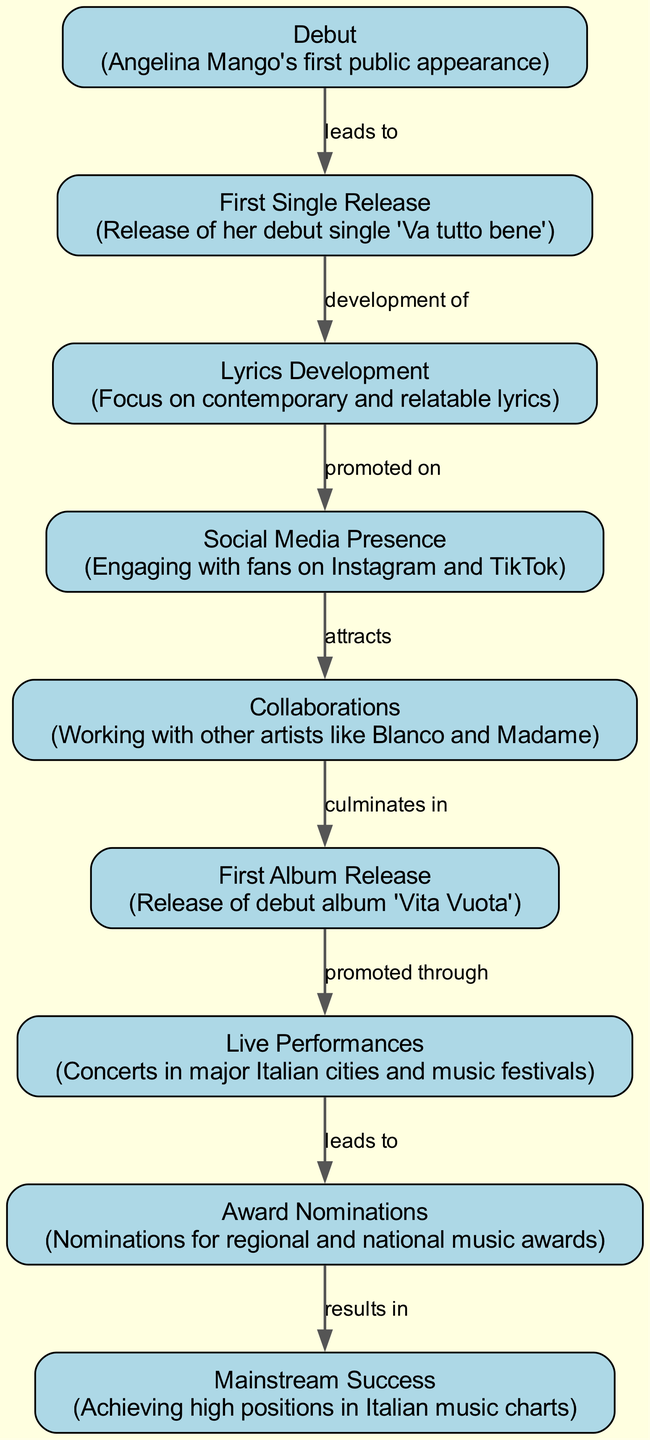What was Angelina Mango's first public appearance? According to the diagram, the first public appearance of Angelina Mango is labeled "Debut."
Answer: Debut What is the title of Angelina Mango's debut single? The diagram indicates that her first single release is "Va tutto bene."
Answer: Va tutto bene What type of lyrics does Angelina Mango focus on? The diagram describes that her lyrics development focuses on contemporary and relatable lyrics.
Answer: Contemporary and relatable Which platform does Angelina Mango use to engage with her fans? The diagram states that she engages with fans primarily on Instagram and TikTok under the "Social Media Presence" section.
Answer: Instagram and TikTok How many collaborations are mentioned in the diagram? The diagram mentions one specific collaboration with other artists, such as Blanco and Madame, under the "Collaborations" node.
Answer: One What does "live performances" promote? The diagram shows that live performances promote the "First Album Release," indicating that concerts facilitate awareness of her debut album.
Answer: First Album Release Which stage in the diagram directly precedes "mainstream success"? The diagram indicates that "Award Nominations" results in "Mainstream Success," making it the immediate preceding stage.
Answer: Award Nominations What are the two major outcomes of Angelina Mango’s live performances according to the diagram? The diagram notes that "Live Performances" lead to "Award Nominations" and is pivotal for promoting her album, showing it is a significant activity with multiple results.
Answer: Award Nominations and promotes First Album Release How do lyrics contribute to Angelina Mango's social media success? The diagram states that her lyrics, which are contemporary and relatable, are promoted on social media, demonstrating that quality lyrics enhance her online visibility and engagement.
Answer: Promoted on social media 